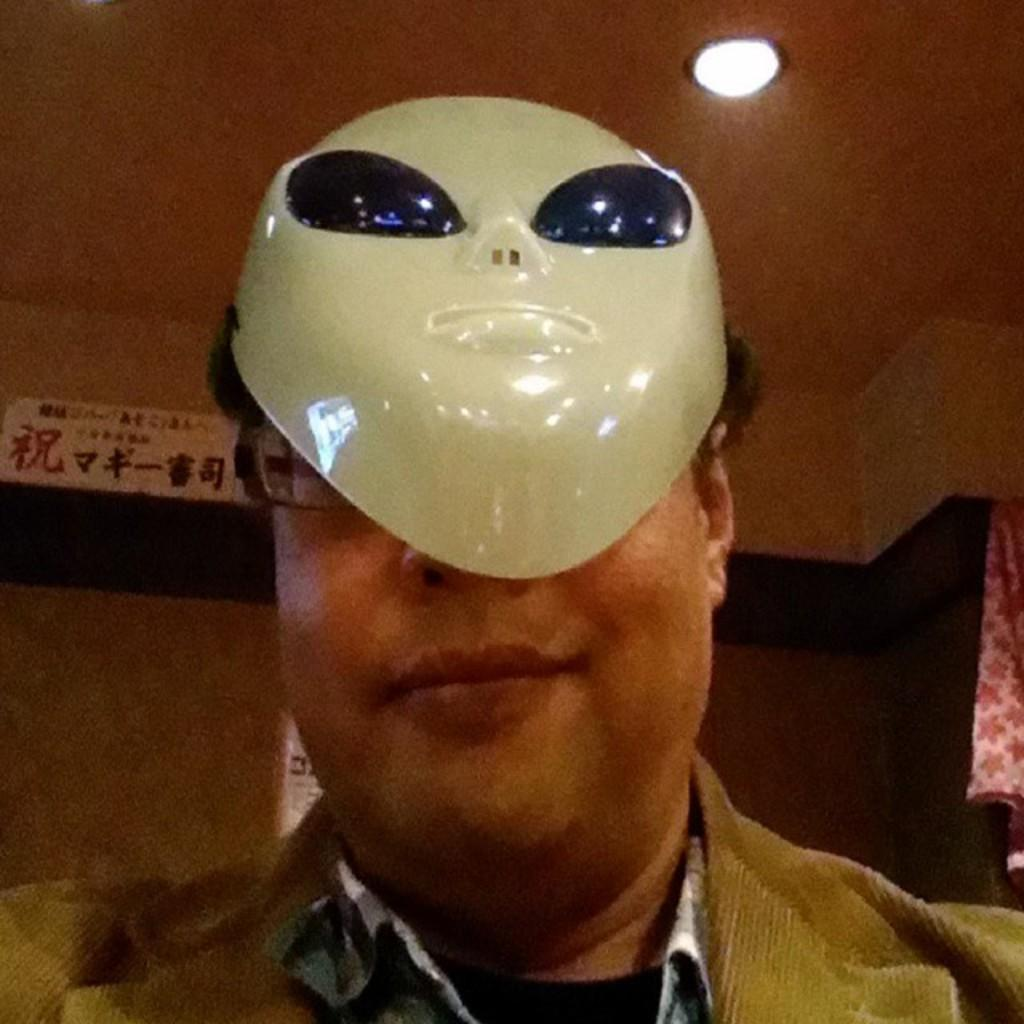Who or what is present in the image? There is a person in the image. Can you describe the person's attire? The person is wearing clothes and a mask. What can be seen at the top of the image? There is a light at the top of the image. What is located on the right side of the image? There is a cloth on the right side of the image. What type of window can be seen in the image? There is no window present in the image. Can you point out the map in the image? There is no map present in the image. 